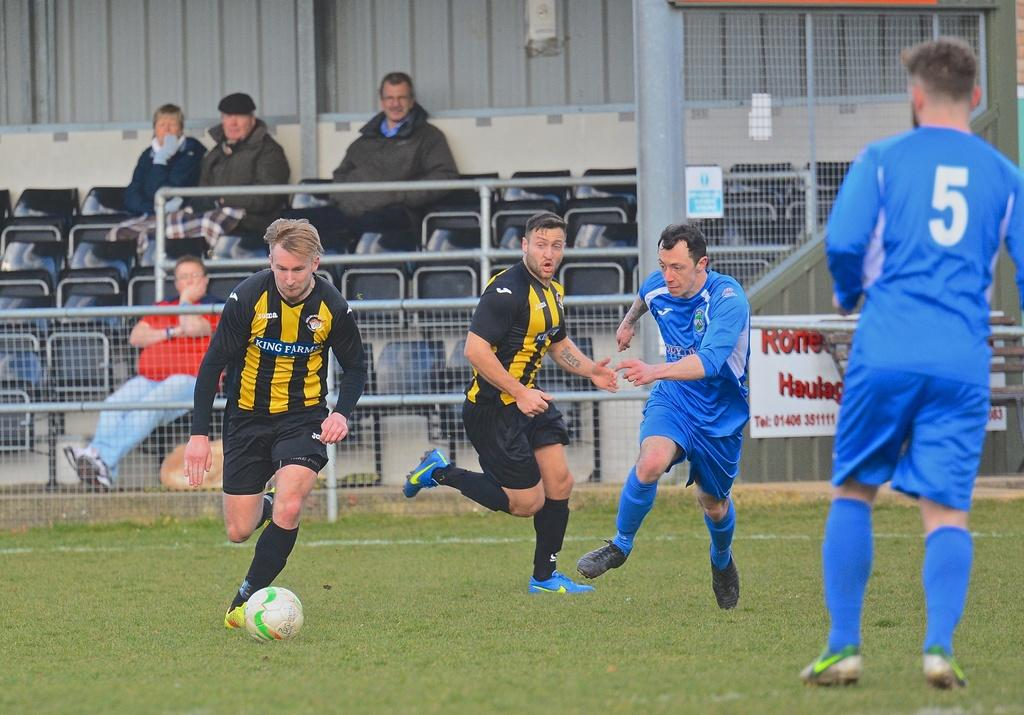Provide a one-sentence caption for the provided image. A man in a King Farms soccer jersey kicks a soccer ball at a game. 